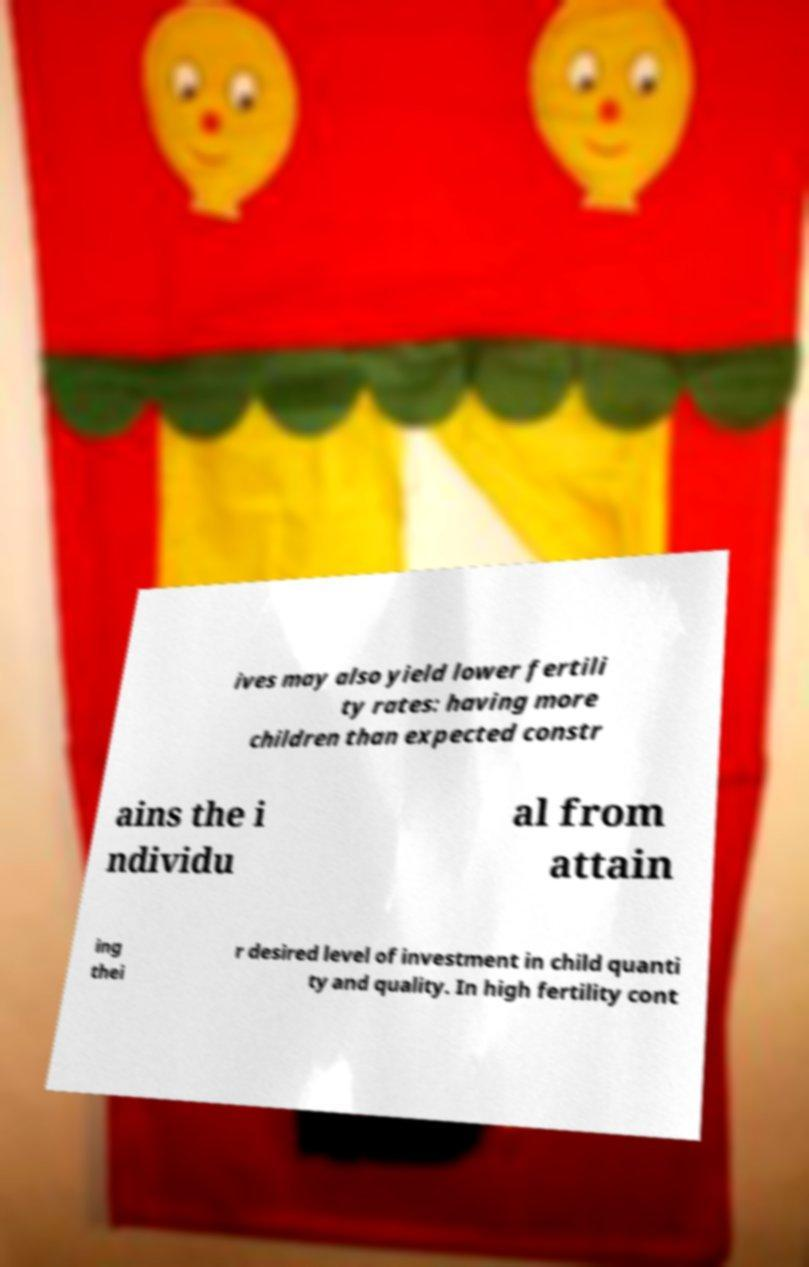I need the written content from this picture converted into text. Can you do that? ives may also yield lower fertili ty rates: having more children than expected constr ains the i ndividu al from attain ing thei r desired level of investment in child quanti ty and quality. In high fertility cont 